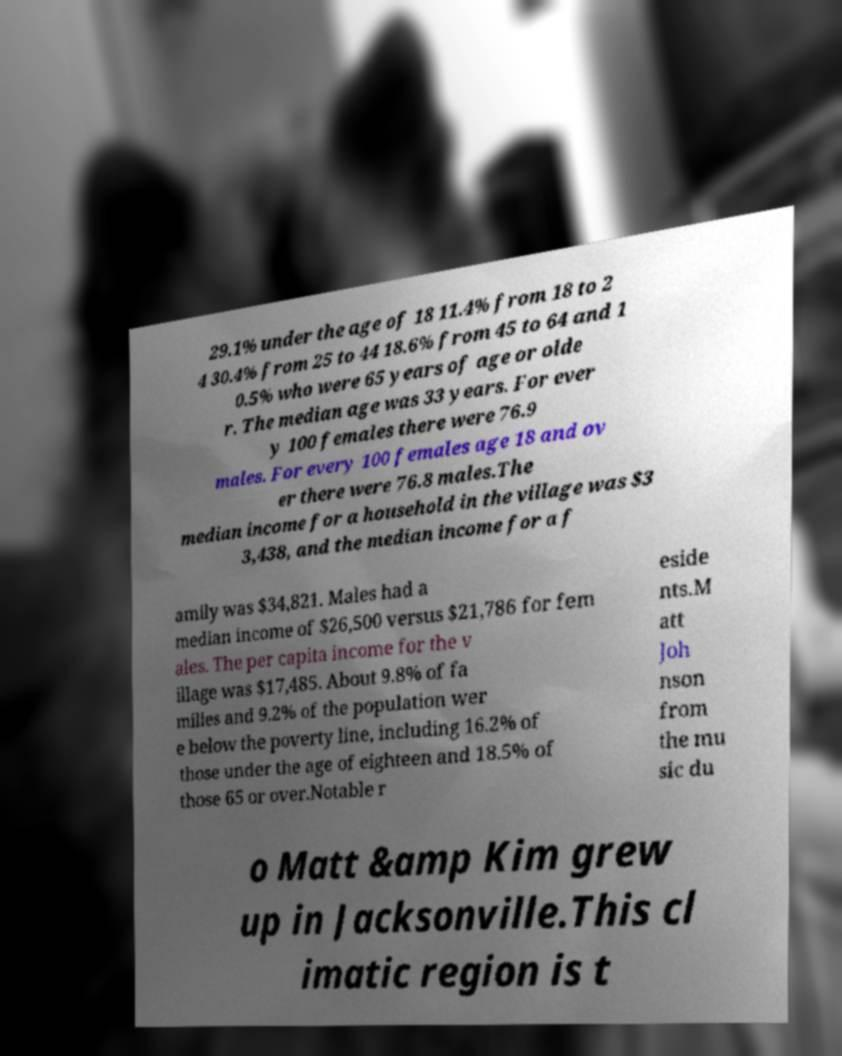There's text embedded in this image that I need extracted. Can you transcribe it verbatim? 29.1% under the age of 18 11.4% from 18 to 2 4 30.4% from 25 to 44 18.6% from 45 to 64 and 1 0.5% who were 65 years of age or olde r. The median age was 33 years. For ever y 100 females there were 76.9 males. For every 100 females age 18 and ov er there were 76.8 males.The median income for a household in the village was $3 3,438, and the median income for a f amily was $34,821. Males had a median income of $26,500 versus $21,786 for fem ales. The per capita income for the v illage was $17,485. About 9.8% of fa milies and 9.2% of the population wer e below the poverty line, including 16.2% of those under the age of eighteen and 18.5% of those 65 or over.Notable r eside nts.M att Joh nson from the mu sic du o Matt &amp Kim grew up in Jacksonville.This cl imatic region is t 